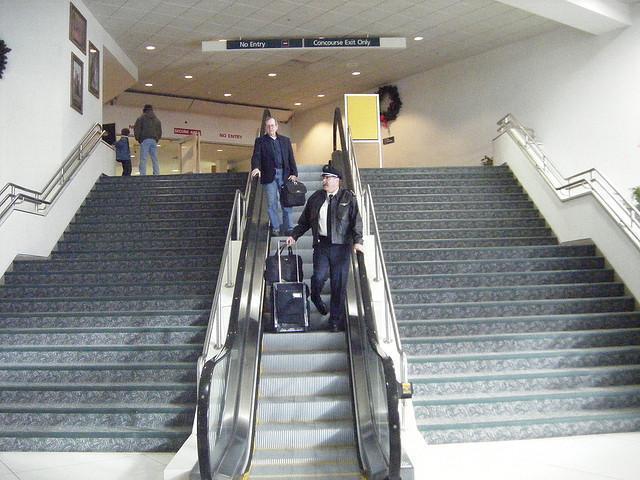Where are the two old men located in?
Select the accurate response from the four choices given to answer the question.
Options: Train station, ferry station, shopping mall, airport. Airport. 